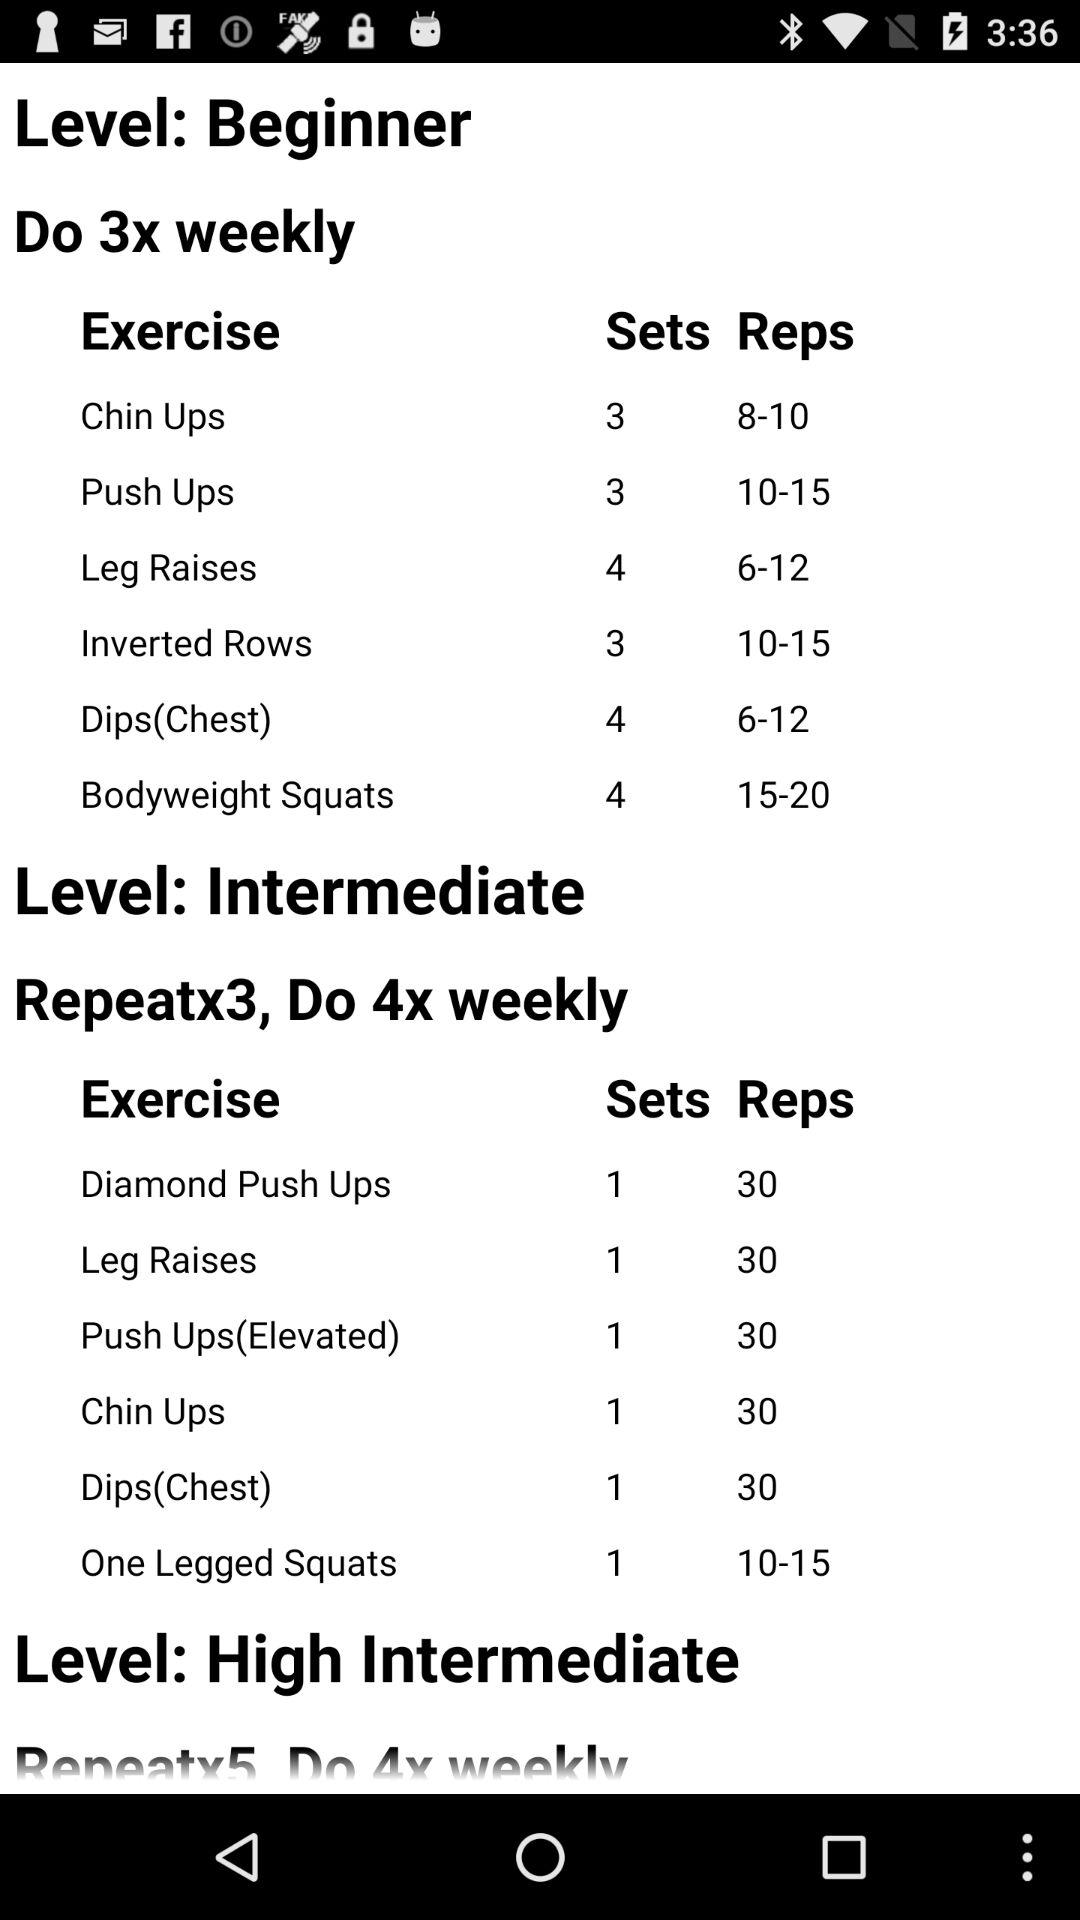How many reps of push ups should we do at the intermediate level? You should do 30 reps of push ups at the intermediate level. 